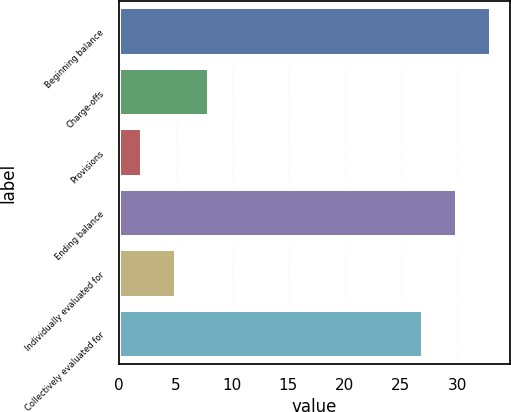<chart> <loc_0><loc_0><loc_500><loc_500><bar_chart><fcel>Beginning balance<fcel>Charge-offs<fcel>Provisions<fcel>Ending balance<fcel>Individually evaluated for<fcel>Collectively evaluated for<nl><fcel>33<fcel>8<fcel>2<fcel>30<fcel>5<fcel>27<nl></chart> 